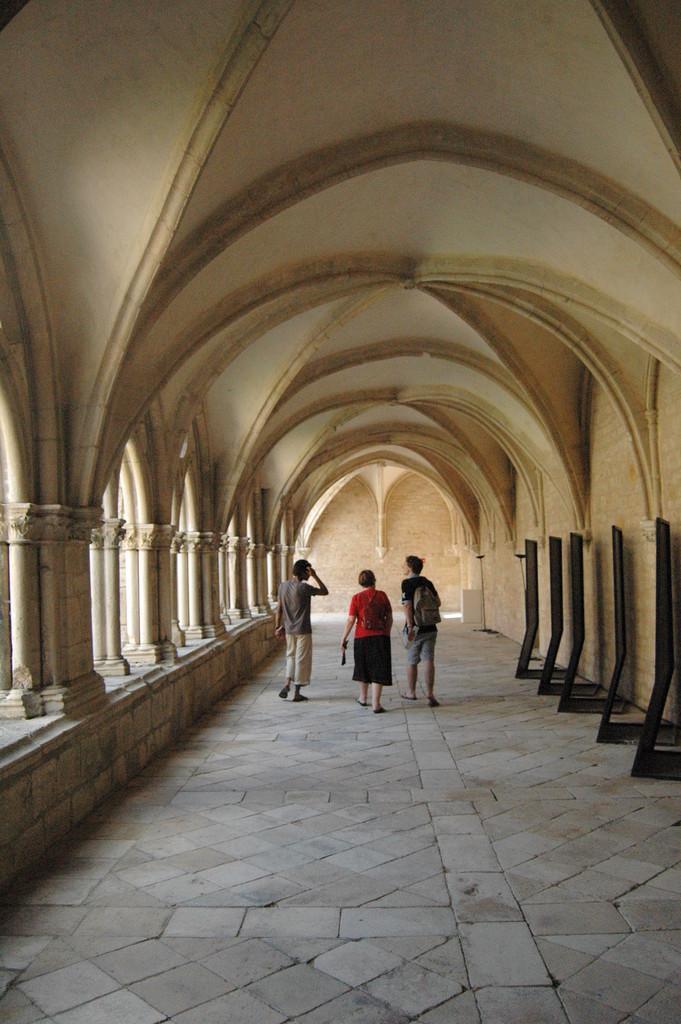Describe this image in one or two sentences. In this picture I can see the inside view of a building. There are three persons standing. I can see pillars and some other objects. 